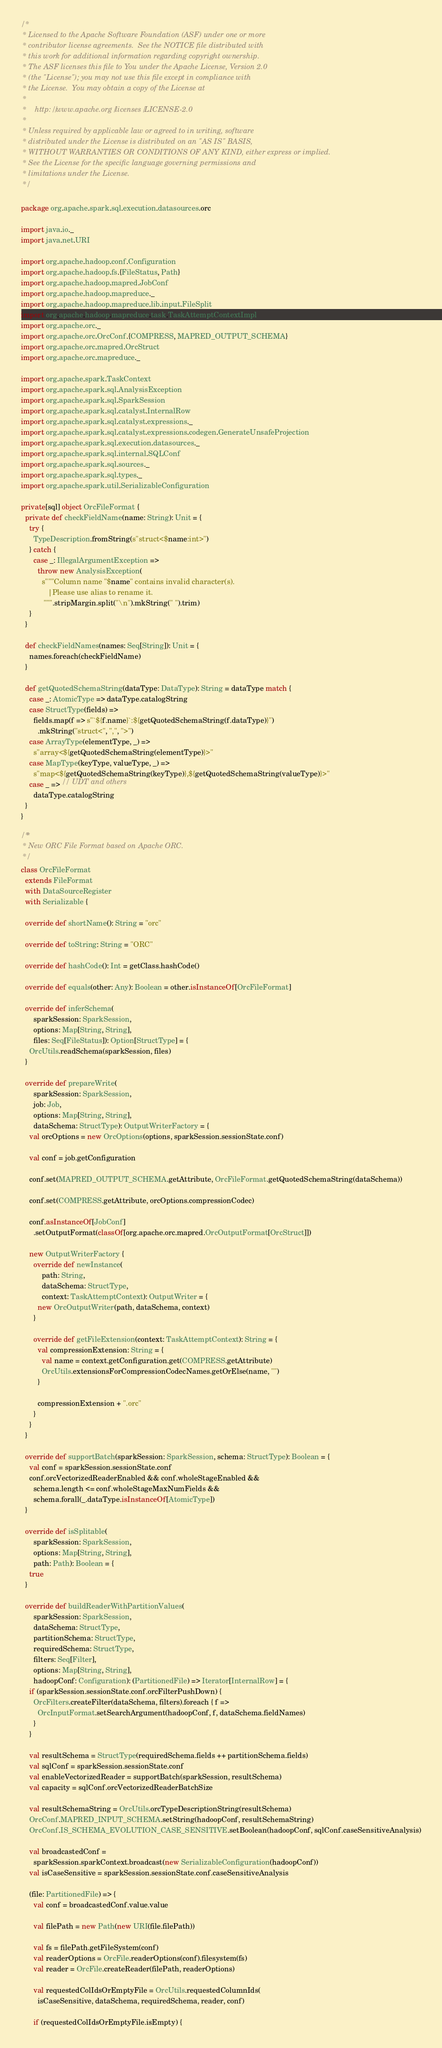<code> <loc_0><loc_0><loc_500><loc_500><_Scala_>/*
 * Licensed to the Apache Software Foundation (ASF) under one or more
 * contributor license agreements.  See the NOTICE file distributed with
 * this work for additional information regarding copyright ownership.
 * The ASF licenses this file to You under the Apache License, Version 2.0
 * (the "License"); you may not use this file except in compliance with
 * the License.  You may obtain a copy of the License at
 *
 *    http://www.apache.org/licenses/LICENSE-2.0
 *
 * Unless required by applicable law or agreed to in writing, software
 * distributed under the License is distributed on an "AS IS" BASIS,
 * WITHOUT WARRANTIES OR CONDITIONS OF ANY KIND, either express or implied.
 * See the License for the specific language governing permissions and
 * limitations under the License.
 */

package org.apache.spark.sql.execution.datasources.orc

import java.io._
import java.net.URI

import org.apache.hadoop.conf.Configuration
import org.apache.hadoop.fs.{FileStatus, Path}
import org.apache.hadoop.mapred.JobConf
import org.apache.hadoop.mapreduce._
import org.apache.hadoop.mapreduce.lib.input.FileSplit
import org.apache.hadoop.mapreduce.task.TaskAttemptContextImpl
import org.apache.orc._
import org.apache.orc.OrcConf.{COMPRESS, MAPRED_OUTPUT_SCHEMA}
import org.apache.orc.mapred.OrcStruct
import org.apache.orc.mapreduce._

import org.apache.spark.TaskContext
import org.apache.spark.sql.AnalysisException
import org.apache.spark.sql.SparkSession
import org.apache.spark.sql.catalyst.InternalRow
import org.apache.spark.sql.catalyst.expressions._
import org.apache.spark.sql.catalyst.expressions.codegen.GenerateUnsafeProjection
import org.apache.spark.sql.execution.datasources._
import org.apache.spark.sql.internal.SQLConf
import org.apache.spark.sql.sources._
import org.apache.spark.sql.types._
import org.apache.spark.util.SerializableConfiguration

private[sql] object OrcFileFormat {
  private def checkFieldName(name: String): Unit = {
    try {
      TypeDescription.fromString(s"struct<$name:int>")
    } catch {
      case _: IllegalArgumentException =>
        throw new AnalysisException(
          s"""Column name "$name" contains invalid character(s).
             |Please use alias to rename it.
           """.stripMargin.split("\n").mkString(" ").trim)
    }
  }

  def checkFieldNames(names: Seq[String]): Unit = {
    names.foreach(checkFieldName)
  }

  def getQuotedSchemaString(dataType: DataType): String = dataType match {
    case _: AtomicType => dataType.catalogString
    case StructType(fields) =>
      fields.map(f => s"`${f.name}`:${getQuotedSchemaString(f.dataType)}")
        .mkString("struct<", ",", ">")
    case ArrayType(elementType, _) =>
      s"array<${getQuotedSchemaString(elementType)}>"
    case MapType(keyType, valueType, _) =>
      s"map<${getQuotedSchemaString(keyType)},${getQuotedSchemaString(valueType)}>"
    case _ => // UDT and others
      dataType.catalogString
  }
}

/**
 * New ORC File Format based on Apache ORC.
 */
class OrcFileFormat
  extends FileFormat
  with DataSourceRegister
  with Serializable {

  override def shortName(): String = "orc"

  override def toString: String = "ORC"

  override def hashCode(): Int = getClass.hashCode()

  override def equals(other: Any): Boolean = other.isInstanceOf[OrcFileFormat]

  override def inferSchema(
      sparkSession: SparkSession,
      options: Map[String, String],
      files: Seq[FileStatus]): Option[StructType] = {
    OrcUtils.readSchema(sparkSession, files)
  }

  override def prepareWrite(
      sparkSession: SparkSession,
      job: Job,
      options: Map[String, String],
      dataSchema: StructType): OutputWriterFactory = {
    val orcOptions = new OrcOptions(options, sparkSession.sessionState.conf)

    val conf = job.getConfiguration

    conf.set(MAPRED_OUTPUT_SCHEMA.getAttribute, OrcFileFormat.getQuotedSchemaString(dataSchema))

    conf.set(COMPRESS.getAttribute, orcOptions.compressionCodec)

    conf.asInstanceOf[JobConf]
      .setOutputFormat(classOf[org.apache.orc.mapred.OrcOutputFormat[OrcStruct]])

    new OutputWriterFactory {
      override def newInstance(
          path: String,
          dataSchema: StructType,
          context: TaskAttemptContext): OutputWriter = {
        new OrcOutputWriter(path, dataSchema, context)
      }

      override def getFileExtension(context: TaskAttemptContext): String = {
        val compressionExtension: String = {
          val name = context.getConfiguration.get(COMPRESS.getAttribute)
          OrcUtils.extensionsForCompressionCodecNames.getOrElse(name, "")
        }

        compressionExtension + ".orc"
      }
    }
  }

  override def supportBatch(sparkSession: SparkSession, schema: StructType): Boolean = {
    val conf = sparkSession.sessionState.conf
    conf.orcVectorizedReaderEnabled && conf.wholeStageEnabled &&
      schema.length <= conf.wholeStageMaxNumFields &&
      schema.forall(_.dataType.isInstanceOf[AtomicType])
  }

  override def isSplitable(
      sparkSession: SparkSession,
      options: Map[String, String],
      path: Path): Boolean = {
    true
  }

  override def buildReaderWithPartitionValues(
      sparkSession: SparkSession,
      dataSchema: StructType,
      partitionSchema: StructType,
      requiredSchema: StructType,
      filters: Seq[Filter],
      options: Map[String, String],
      hadoopConf: Configuration): (PartitionedFile) => Iterator[InternalRow] = {
    if (sparkSession.sessionState.conf.orcFilterPushDown) {
      OrcFilters.createFilter(dataSchema, filters).foreach { f =>
        OrcInputFormat.setSearchArgument(hadoopConf, f, dataSchema.fieldNames)
      }
    }

    val resultSchema = StructType(requiredSchema.fields ++ partitionSchema.fields)
    val sqlConf = sparkSession.sessionState.conf
    val enableVectorizedReader = supportBatch(sparkSession, resultSchema)
    val capacity = sqlConf.orcVectorizedReaderBatchSize

    val resultSchemaString = OrcUtils.orcTypeDescriptionString(resultSchema)
    OrcConf.MAPRED_INPUT_SCHEMA.setString(hadoopConf, resultSchemaString)
    OrcConf.IS_SCHEMA_EVOLUTION_CASE_SENSITIVE.setBoolean(hadoopConf, sqlConf.caseSensitiveAnalysis)

    val broadcastedConf =
      sparkSession.sparkContext.broadcast(new SerializableConfiguration(hadoopConf))
    val isCaseSensitive = sparkSession.sessionState.conf.caseSensitiveAnalysis

    (file: PartitionedFile) => {
      val conf = broadcastedConf.value.value

      val filePath = new Path(new URI(file.filePath))

      val fs = filePath.getFileSystem(conf)
      val readerOptions = OrcFile.readerOptions(conf).filesystem(fs)
      val reader = OrcFile.createReader(filePath, readerOptions)

      val requestedColIdsOrEmptyFile = OrcUtils.requestedColumnIds(
        isCaseSensitive, dataSchema, requiredSchema, reader, conf)

      if (requestedColIdsOrEmptyFile.isEmpty) {</code> 